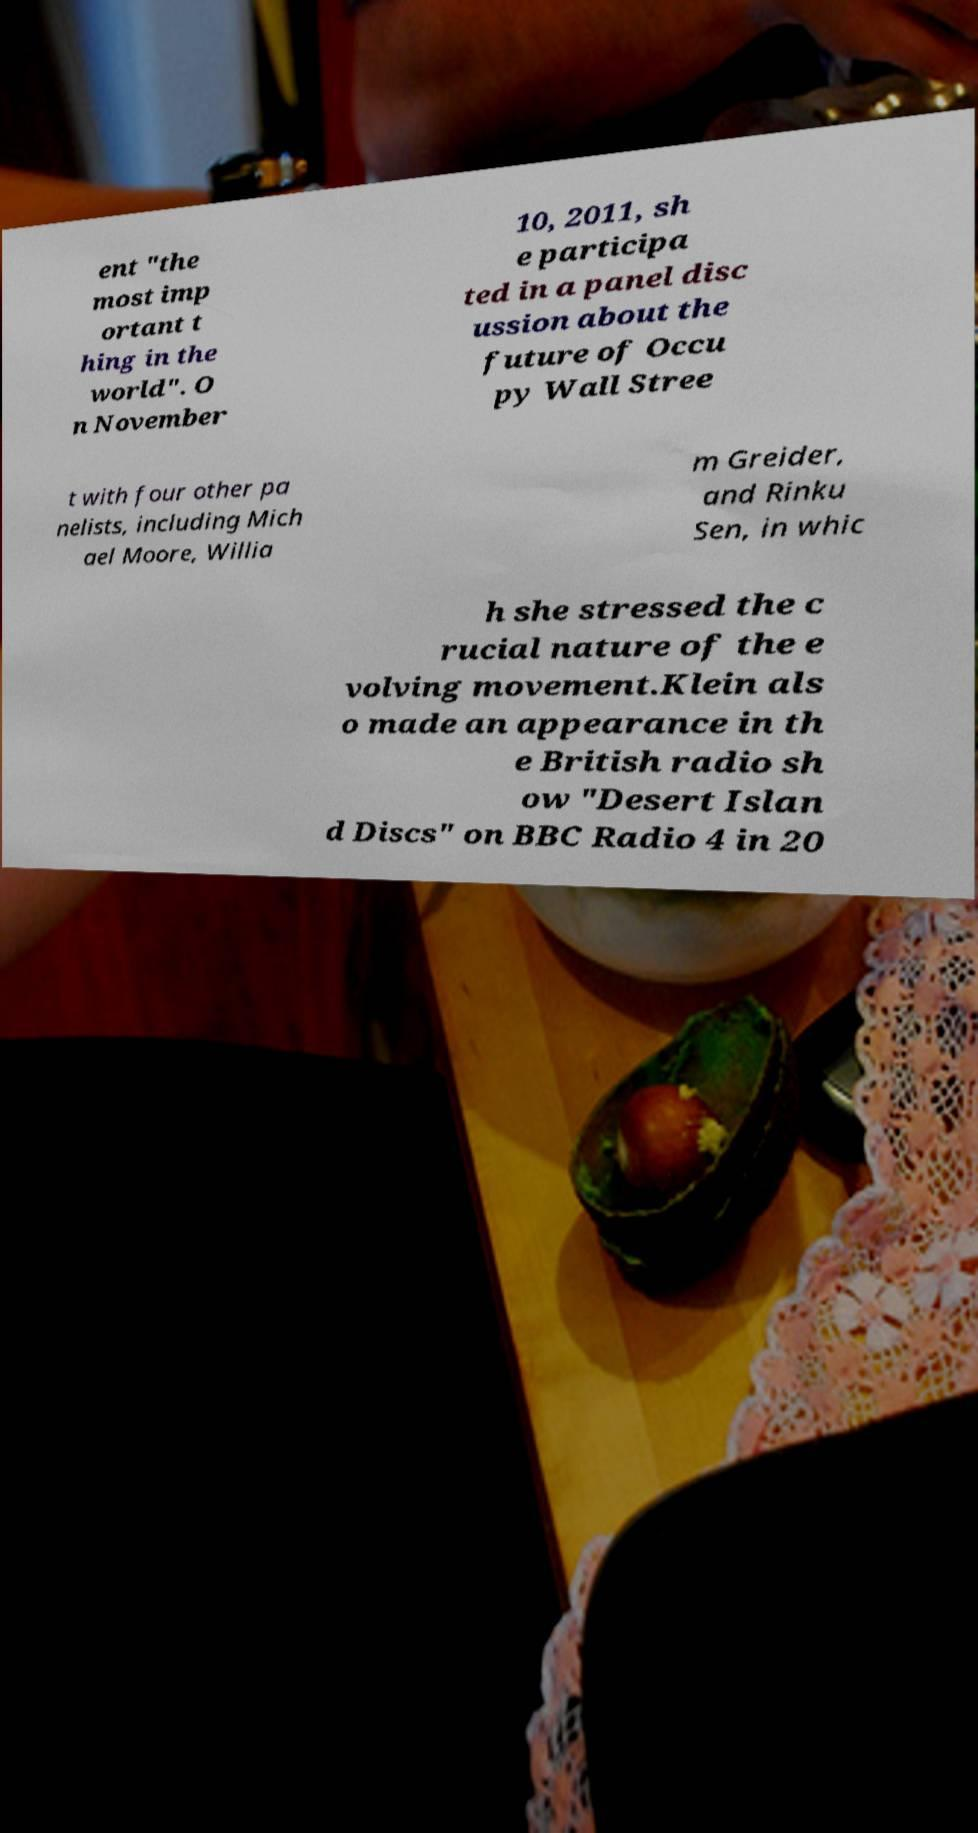There's text embedded in this image that I need extracted. Can you transcribe it verbatim? ent "the most imp ortant t hing in the world". O n November 10, 2011, sh e participa ted in a panel disc ussion about the future of Occu py Wall Stree t with four other pa nelists, including Mich ael Moore, Willia m Greider, and Rinku Sen, in whic h she stressed the c rucial nature of the e volving movement.Klein als o made an appearance in th e British radio sh ow "Desert Islan d Discs" on BBC Radio 4 in 20 